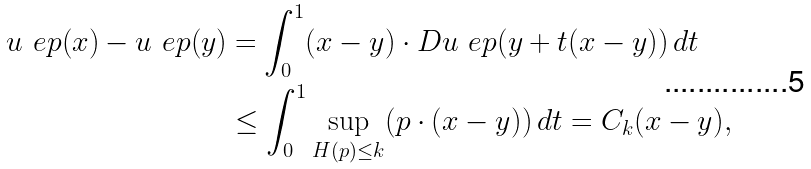<formula> <loc_0><loc_0><loc_500><loc_500>u _ { \ } e p ( x ) - u _ { \ } e p ( y ) & = \int _ { 0 } ^ { 1 } ( x - y ) \cdot D u _ { \ } e p ( y + t ( x - y ) ) \, d t \\ & \leq \int _ { 0 } ^ { 1 } \sup _ { H ( p ) \leq k } ( p \cdot ( x - y ) ) \, d t = C _ { k } ( x - y ) ,</formula> 